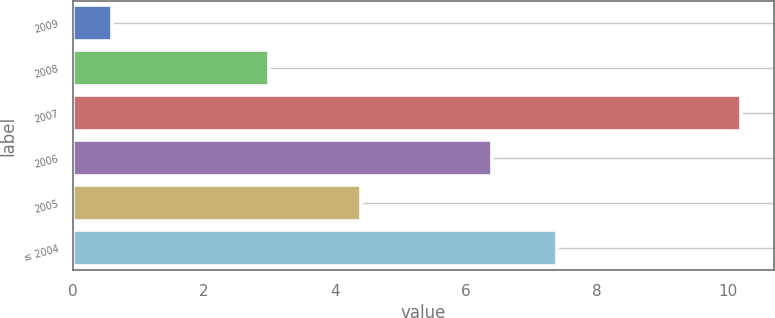Convert chart. <chart><loc_0><loc_0><loc_500><loc_500><bar_chart><fcel>2009<fcel>2008<fcel>2007<fcel>2006<fcel>2005<fcel>≤ 2004<nl><fcel>0.6<fcel>3<fcel>10.2<fcel>6.4<fcel>4.4<fcel>7.4<nl></chart> 